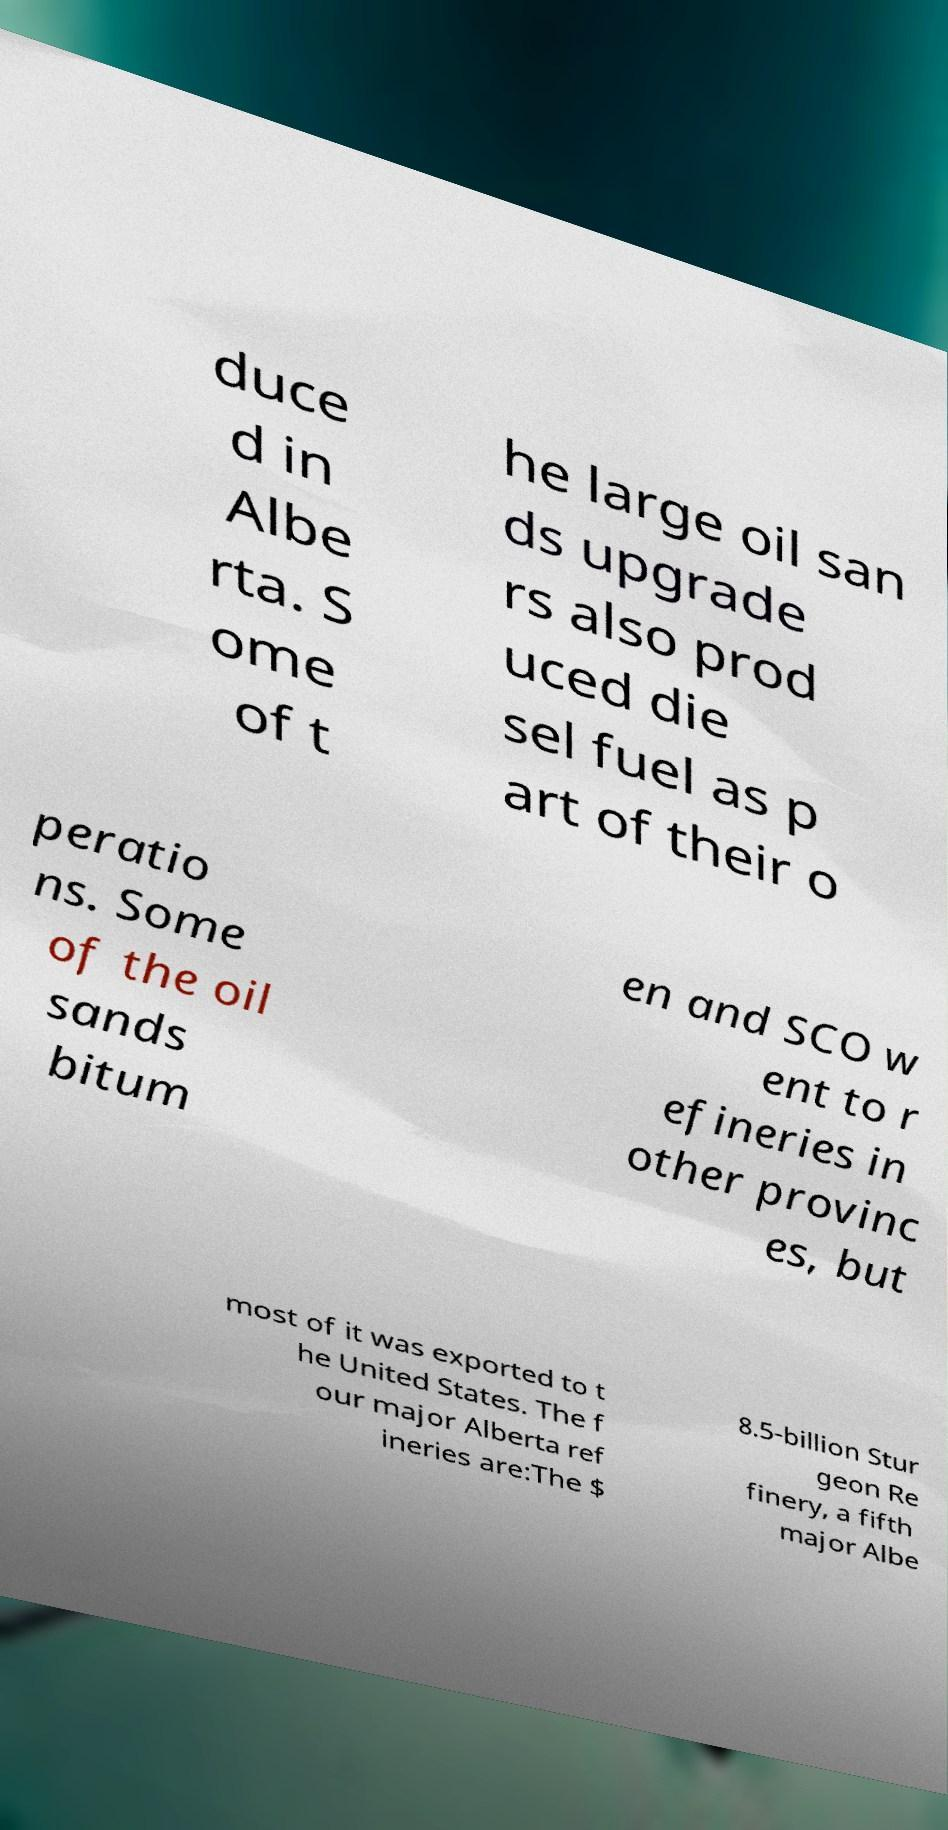There's text embedded in this image that I need extracted. Can you transcribe it verbatim? duce d in Albe rta. S ome of t he large oil san ds upgrade rs also prod uced die sel fuel as p art of their o peratio ns. Some of the oil sands bitum en and SCO w ent to r efineries in other provinc es, but most of it was exported to t he United States. The f our major Alberta ref ineries are:The $ 8.5-billion Stur geon Re finery, a fifth major Albe 